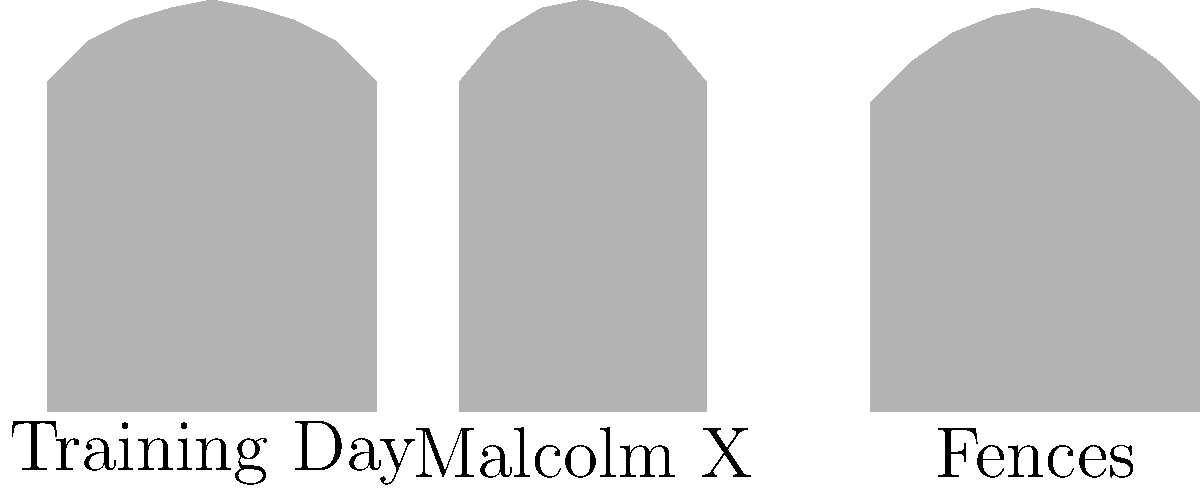Analyze the silhouettes representing Denzel Washington's characters in "Training Day," "Malcolm X," and "Fences." Which character's posture suggests the most authoritative presence, and how does this align with Washington's performance in that role? To answer this question, we need to analyze each silhouette and consider how it relates to Denzel Washington's performance in the respective roles:

1. Training Day (Alonzo Harris):
   - The silhouette shows a broader shoulder width and a slightly tilted head.
   - This suggests a confident, intimidating stance, reflecting Harris's corrupt and domineering nature.

2. Malcolm X (Malcolm X):
   - The silhouette appears taller and more upright.
   - This posture indicates a sense of purpose and leadership, aligning with Malcolm X's role as a civil rights leader.

3. Fences (Troy Maxson):
   - The silhouette shows a slightly hunched posture with rounded shoulders.
   - This suggests a working-class character, carrying the weight of his experiences, fitting Troy's background as a former athlete turned garbage collector.

Among these, the Malcolm X silhouette suggests the most authoritative presence due to its upright, tall stance. This aligns perfectly with Washington's powerful performance as Malcolm X, where he portrayed a charismatic and influential leader. Washington's portrayal captured Malcolm X's commanding presence and ability to captivate audiences, which is reflected in the silhouette's strong, straight posture.

This authoritative body language was crucial to Washington's performance, as it helped convey Malcolm X's transformation from a street hustler to a prominent civil rights leader. The upright stance symbolizes the character's unwavering commitment to his beliefs and his role as a voice for the African American community.
Answer: Malcolm X, due to the upright posture reflecting leadership and authority, aligning with Washington's portrayal of the charismatic civil rights leader. 